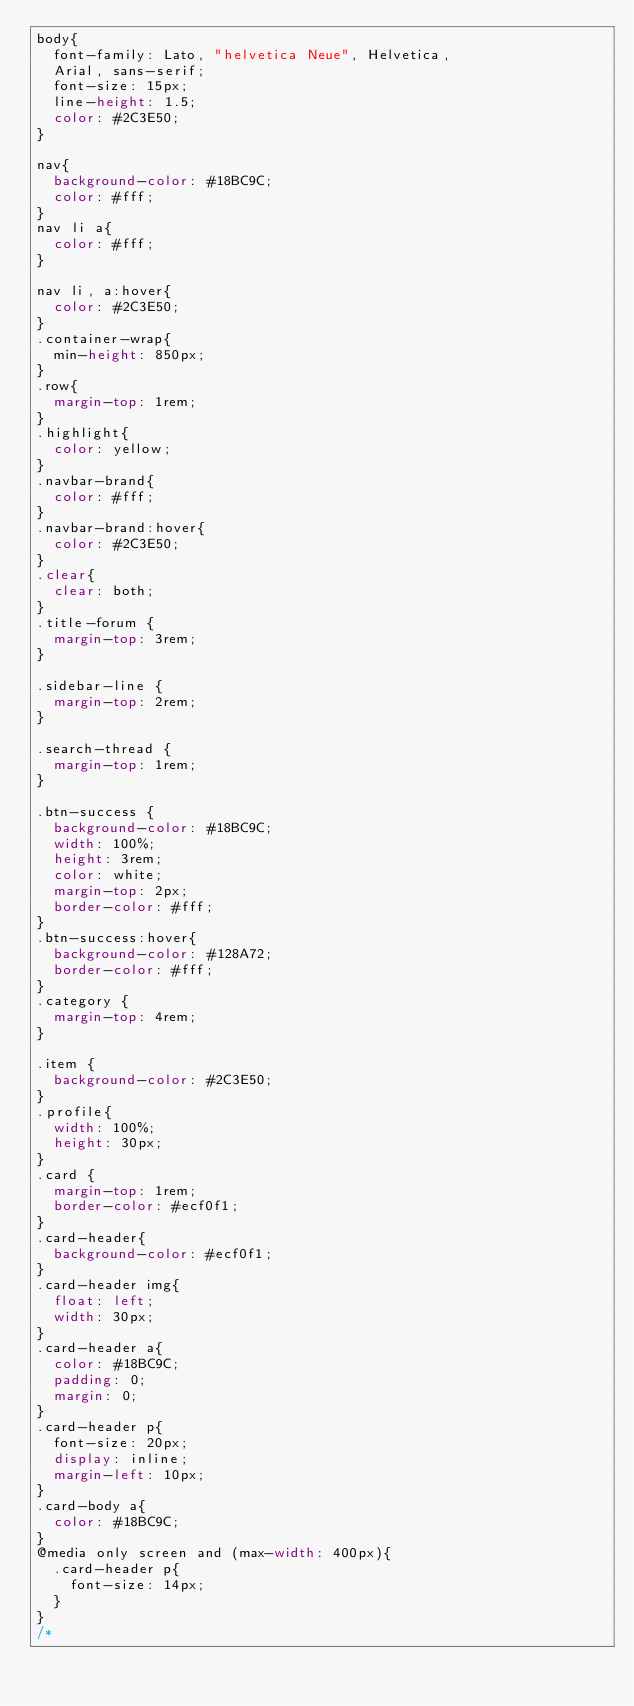Convert code to text. <code><loc_0><loc_0><loc_500><loc_500><_CSS_>body{
	font-family: Lato, "helvetica Neue", Helvetica,
	Arial, sans-serif;
	font-size: 15px;
	line-height: 1.5;
	color: #2C3E50;
}

nav{
	background-color: #18BC9C;
	color: #fff;
}
nav li a{
	color: #fff;
}

nav li, a:hover{
	color: #2C3E50;
}
.container-wrap{
	min-height: 850px;
}
.row{
	margin-top: 1rem;
}
.highlight{
	color: yellow;
}
.navbar-brand{
	color: #fff;
}
.navbar-brand:hover{
	color: #2C3E50;
}
.clear{
	clear: both;
}
.title-forum {
	margin-top: 3rem;
}

.sidebar-line {
	margin-top: 2rem;
}

.search-thread {
	margin-top: 1rem;
}

.btn-success {
	background-color: #18BC9C;
	width: 100%;
	height: 3rem;
	color: white;
	margin-top: 2px;
	border-color: #fff;
}
.btn-success:hover{
	background-color: #128A72;
	border-color: #fff;
}
.category {
	margin-top: 4rem;
}

.item {
	background-color: #2C3E50;
}
.profile{
	width: 100%;
	height: 30px;
}
.card {
	margin-top: 1rem;
	border-color: #ecf0f1;
}
.card-header{
	background-color: #ecf0f1;
}
.card-header img{
	float: left;
	width: 30px;
}
.card-header a{
	color: #18BC9C;
	padding: 0;
	margin: 0;
}
.card-header p{
	font-size: 20px;
	display: inline;
	margin-left: 10px;
}
.card-body a{
	color: #18BC9C;
}
@media only screen and (max-width: 400px){
	.card-header p{
		font-size: 14px;
	}
}
/* </code> 